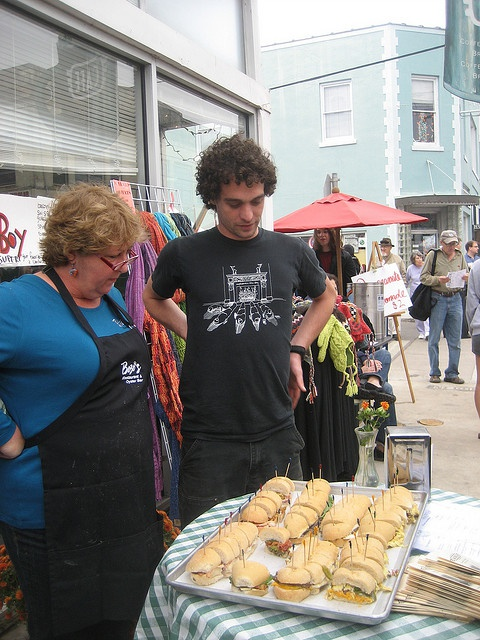Describe the objects in this image and their specific colors. I can see people in black, navy, teal, and brown tones, dining table in black, tan, lightgray, and darkgray tones, people in black, gray, brown, and maroon tones, sandwich in black, tan, and lightgray tones, and people in black, gray, and darkgray tones in this image. 